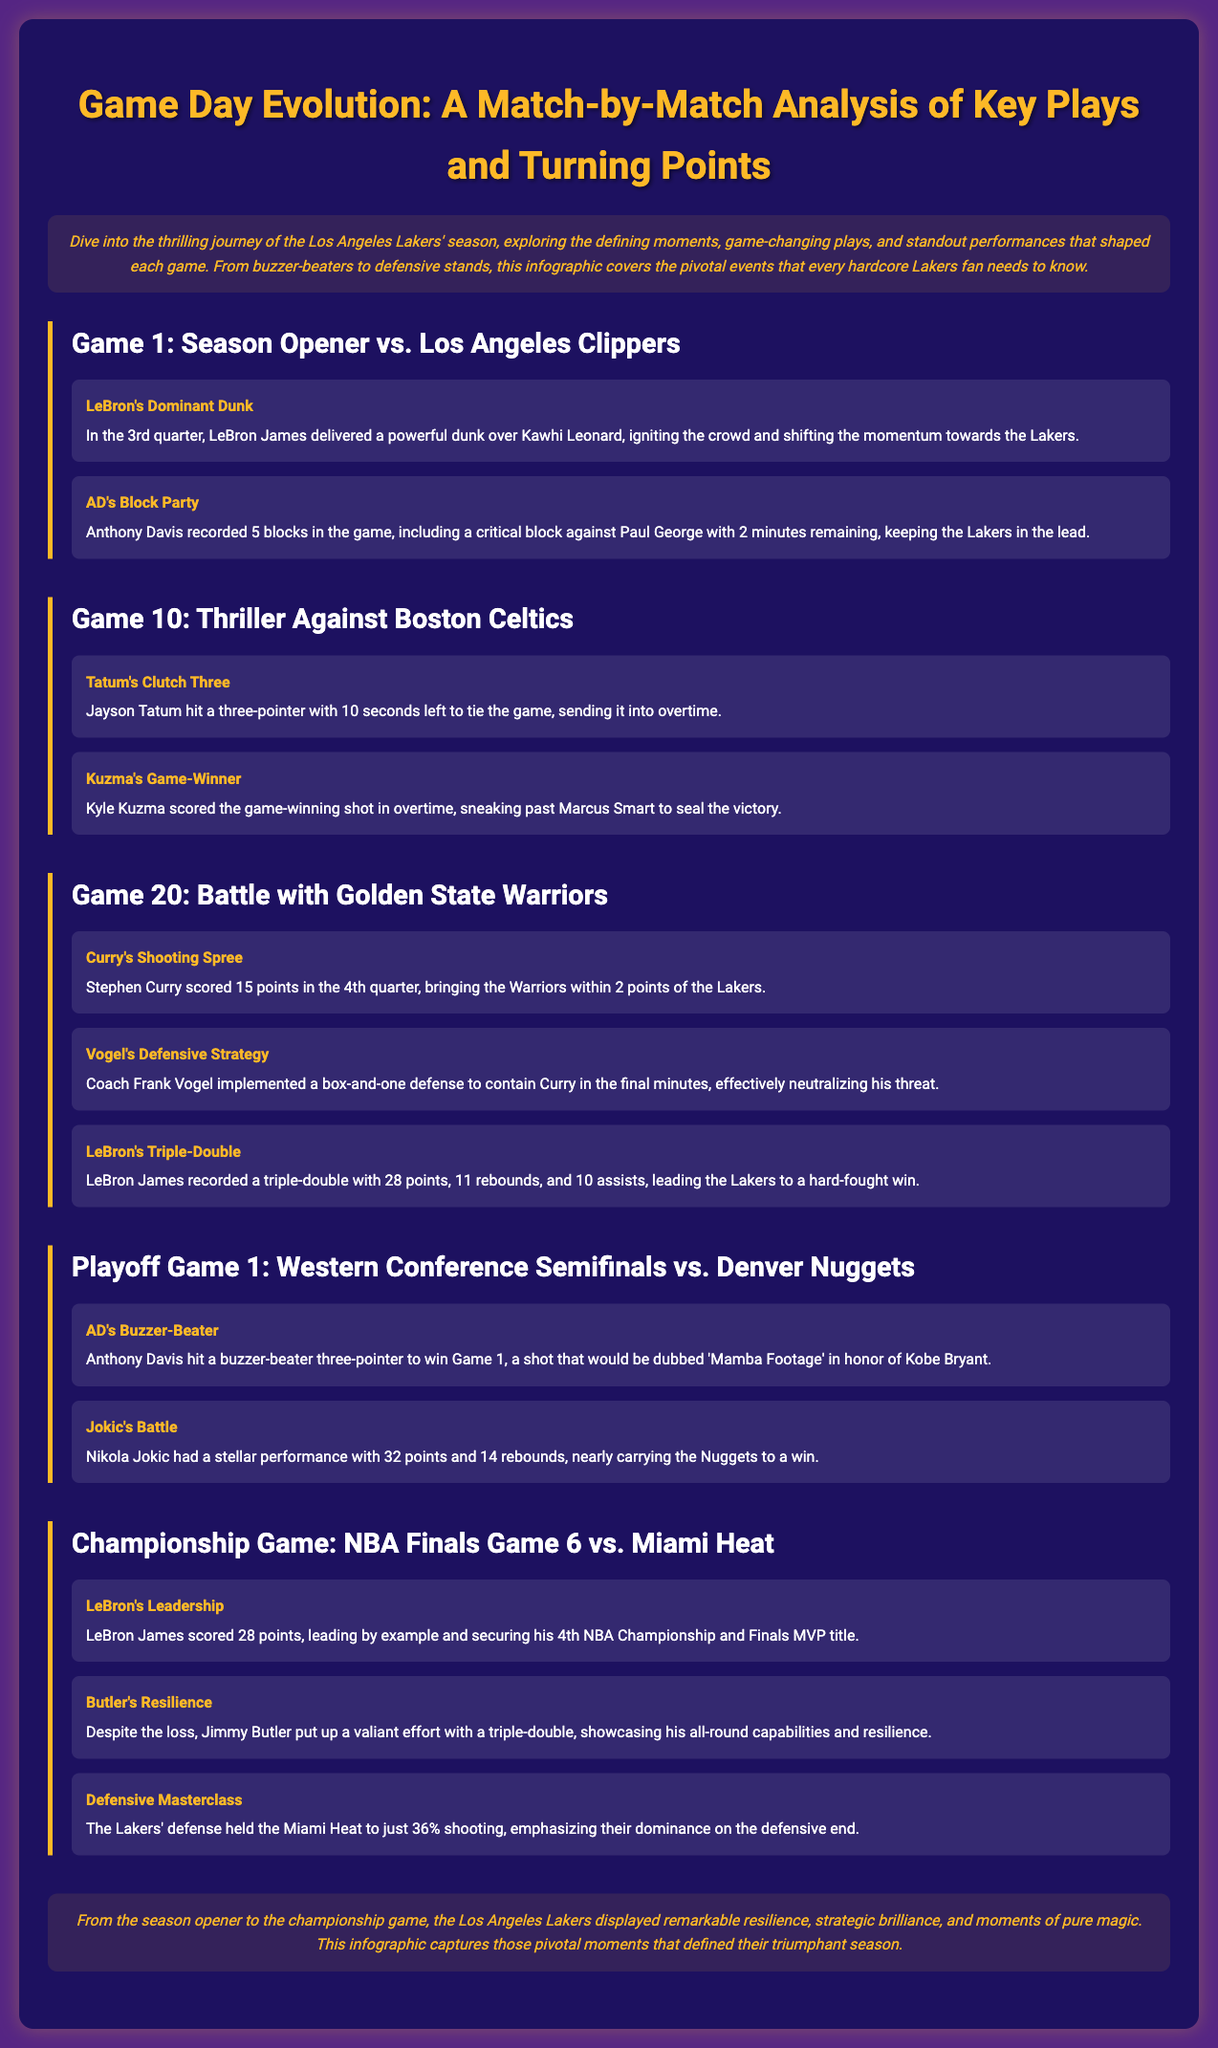what was the notable moment in Game 1? LeBron James delivered a powerful dunk over Kawhi Leonard, which ignited the crowd and shifted momentum towards the Lakers.
Answer: LeBron's Dominant Dunk how many blocks did Anthony Davis record in Game 1? The document specifies that Anthony Davis recorded 5 blocks in the game.
Answer: 5 blocks who scored the game-winning shot in Game 10? Kyle Kuzma scored the game-winning shot in overtime to seal the victory against the Celtics.
Answer: Kyle Kuzma what was Stephen Curry's contribution in Game 20? Stephen Curry scored 15 points in the 4th quarter, bringing the Warriors within 2 points of the Lakers.
Answer: 15 points what was unique about Anthony Davis's shot in the Playoff Game 1? Anthony Davis hit a buzzer-beater three-pointer to win Game 1, which was dubbed 'Mamba Footage' in honor of Kobe Bryant.
Answer: Buzzer-beater three-pointer how did LeBron James perform in the Championship Game? LeBron James scored 28 points, leading by example in the Championship Game against the Miami Heat.
Answer: 28 points which team did the Lakers face in the Championship Game? The Lakers faced the Miami Heat in the Championship Game of the NBA Finals.
Answer: Miami Heat what defensive strategy did Coach Frank Vogel implement in Game 20? Coach Frank Vogel implemented a box-and-one defense to contain Curry in the final minutes of Game 20.
Answer: Box-and-one defense how did the Lakers' defense perform in the Championship Game? The Lakers' defense held the Miami Heat to just 36% shooting, showcasing their defensive dominance.
Answer: 36% shooting 